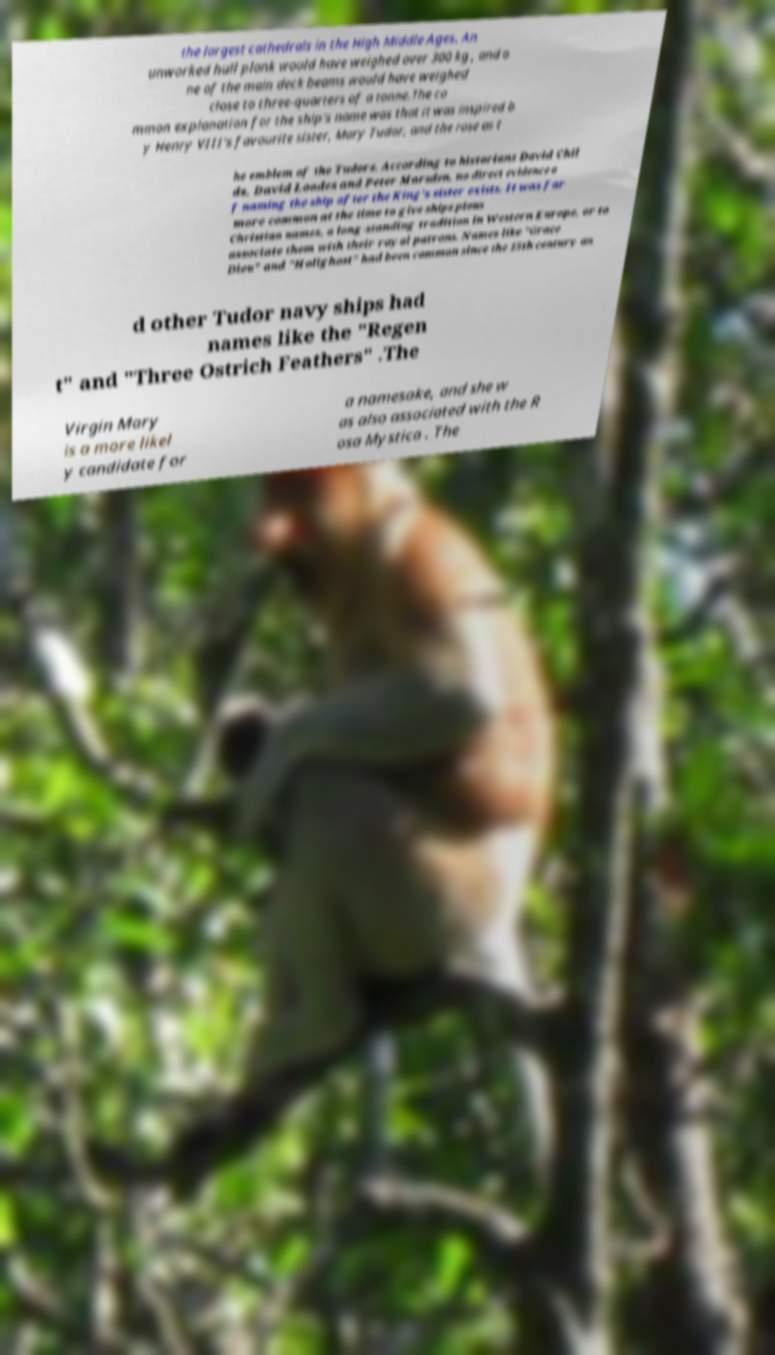Please identify and transcribe the text found in this image. the largest cathedrals in the High Middle Ages. An unworked hull plank would have weighed over 300 kg , and o ne of the main deck beams would have weighed close to three-quarters of a tonne.The co mmon explanation for the ship's name was that it was inspired b y Henry VIII's favourite sister, Mary Tudor, and the rose as t he emblem of the Tudors. According to historians David Chil ds, David Loades and Peter Marsden, no direct evidence o f naming the ship after the King's sister exists. It was far more common at the time to give ships pious Christian names, a long-standing tradition in Western Europe, or to associate them with their royal patrons. Names like "Grace Dieu" and "Holighost" had been common since the 15th century an d other Tudor navy ships had names like the "Regen t" and "Three Ostrich Feathers" .The Virgin Mary is a more likel y candidate for a namesake, and she w as also associated with the R osa Mystica . The 